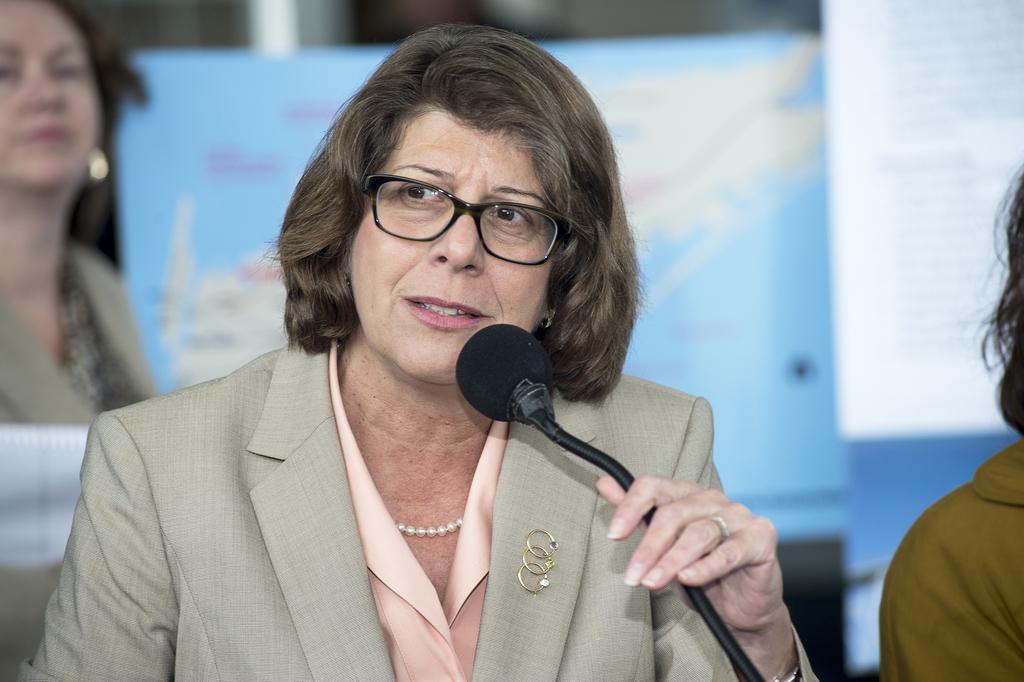Describe this image in one or two sentences. A lady wearing a coat, pearl chain, specs is holding mic and speaking. In the background there is another lady and a banner is over there. 